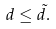<formula> <loc_0><loc_0><loc_500><loc_500>d \leq \tilde { d } .</formula> 